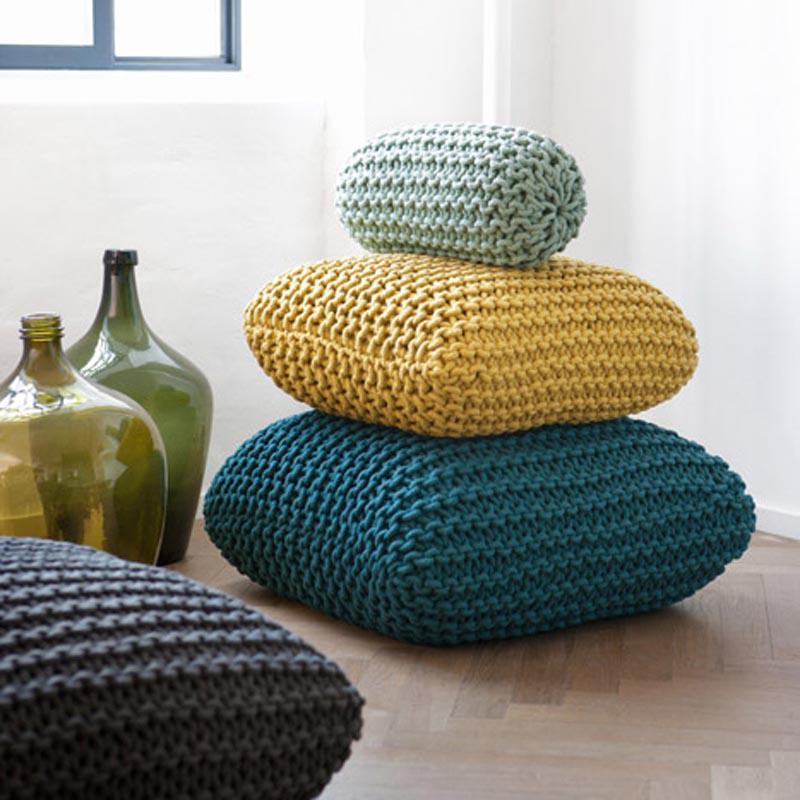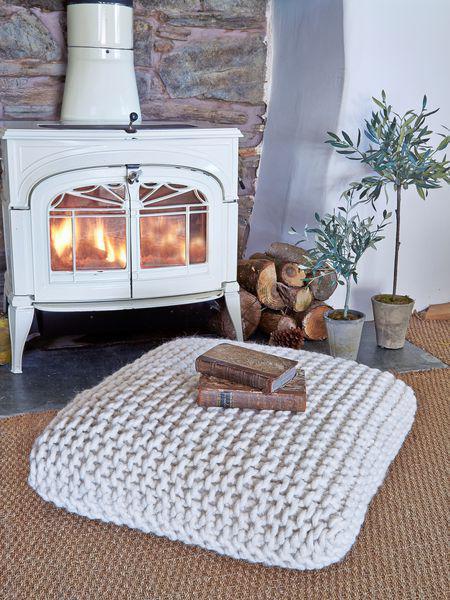The first image is the image on the left, the second image is the image on the right. Given the left and right images, does the statement "Each image contains a squarish knit pillow made of chunky yarn, and at least one image features such a pillow in a cream color." hold true? Answer yes or no. Yes. The first image is the image on the left, the second image is the image on the right. Evaluate the accuracy of this statement regarding the images: "There are at least 3 crochet pillow stacked on top of each other.". Is it true? Answer yes or no. Yes. 